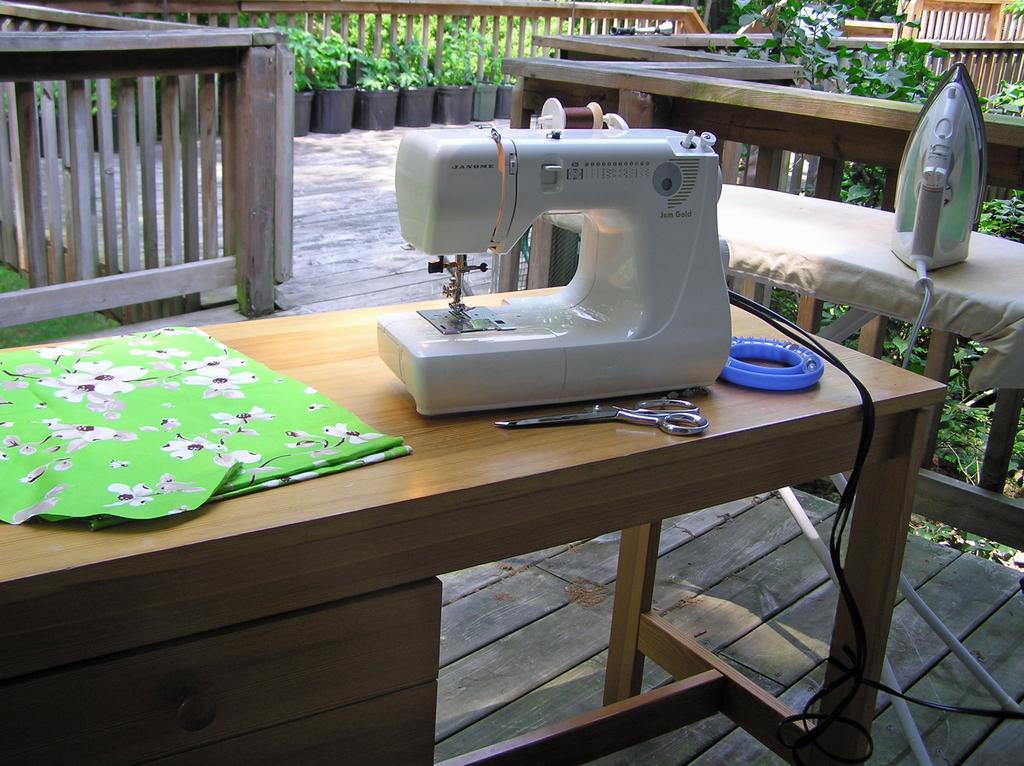Describe this image in one or two sentences. In this picture there is a table in the center. On the table, there is a sewing machine, scissors and a cloth. Behind it there is another table with a iron box. In the background there are hand-grills and plants. 